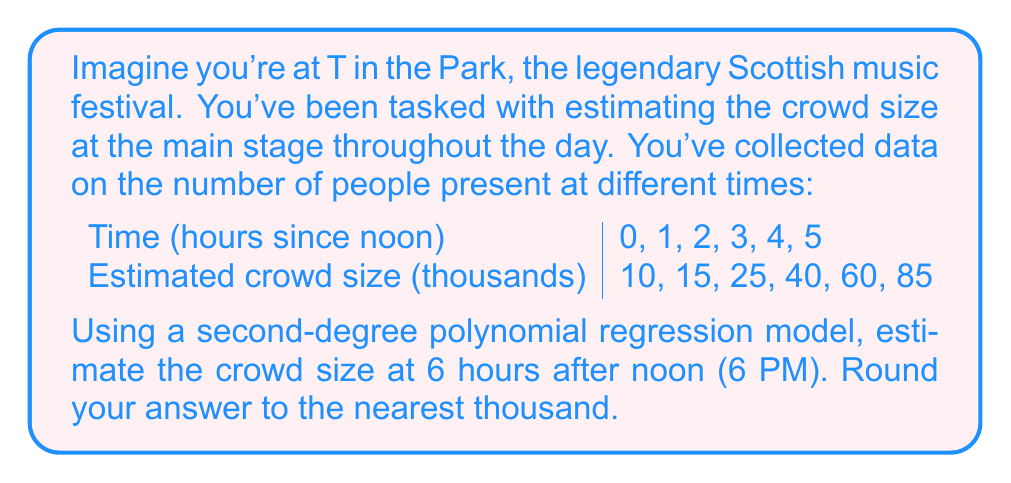Give your solution to this math problem. Let's approach this step-by-step:

1) We're looking for a polynomial of the form $y = ax^2 + bx + c$, where $y$ is the crowd size in thousands and $x$ is the time in hours since noon.

2) To find the coefficients $a$, $b$, and $c$, we can use a polynomial regression calculator or spreadsheet software. After inputting our data points, we get the following equation:

   $y = 2.5x^2 + 2.5x + 10$

3) To estimate the crowd size at 6 PM (6 hours after noon), we simply plug $x = 6$ into our equation:

   $y = 2.5(6)^2 + 2.5(6) + 10$

4) Let's calculate this step-by-step:
   
   $y = 2.5(36) + 2.5(6) + 10$
   $y = 90 + 15 + 10$
   $y = 115$

5) Therefore, the estimated crowd size at 6 PM is 115 thousand people.

6) Rounding to the nearest thousand, we get 115,000 people.
Answer: 115,000 people 